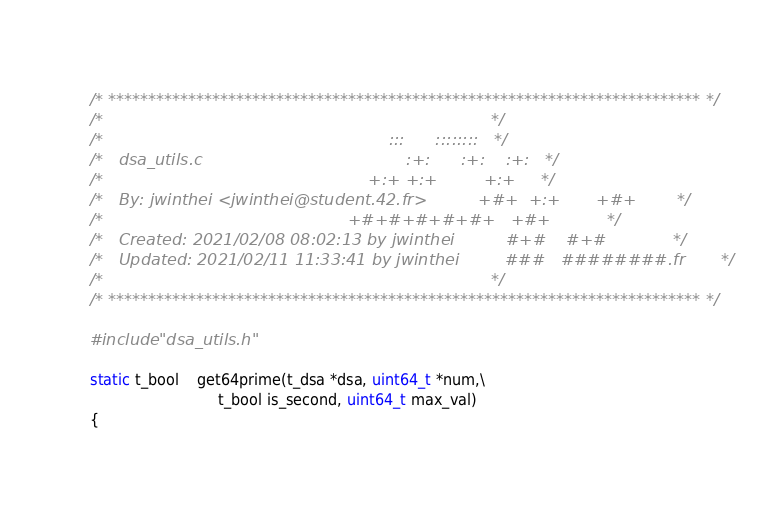<code> <loc_0><loc_0><loc_500><loc_500><_C_>/* ************************************************************************** */
/*                                                                            */
/*                                                        :::      ::::::::   */
/*   dsa_utils.c                                        :+:      :+:    :+:   */
/*                                                    +:+ +:+         +:+     */
/*   By: jwinthei <jwinthei@student.42.fr>          +#+  +:+       +#+        */
/*                                                +#+#+#+#+#+   +#+           */
/*   Created: 2021/02/08 08:02:13 by jwinthei          #+#    #+#             */
/*   Updated: 2021/02/11 11:33:41 by jwinthei         ###   ########.fr       */
/*                                                                            */
/* ************************************************************************** */

#include "dsa_utils.h"

static t_bool	get64prime(t_dsa *dsa, uint64_t *num,\
							t_bool is_second, uint64_t max_val)
{</code> 